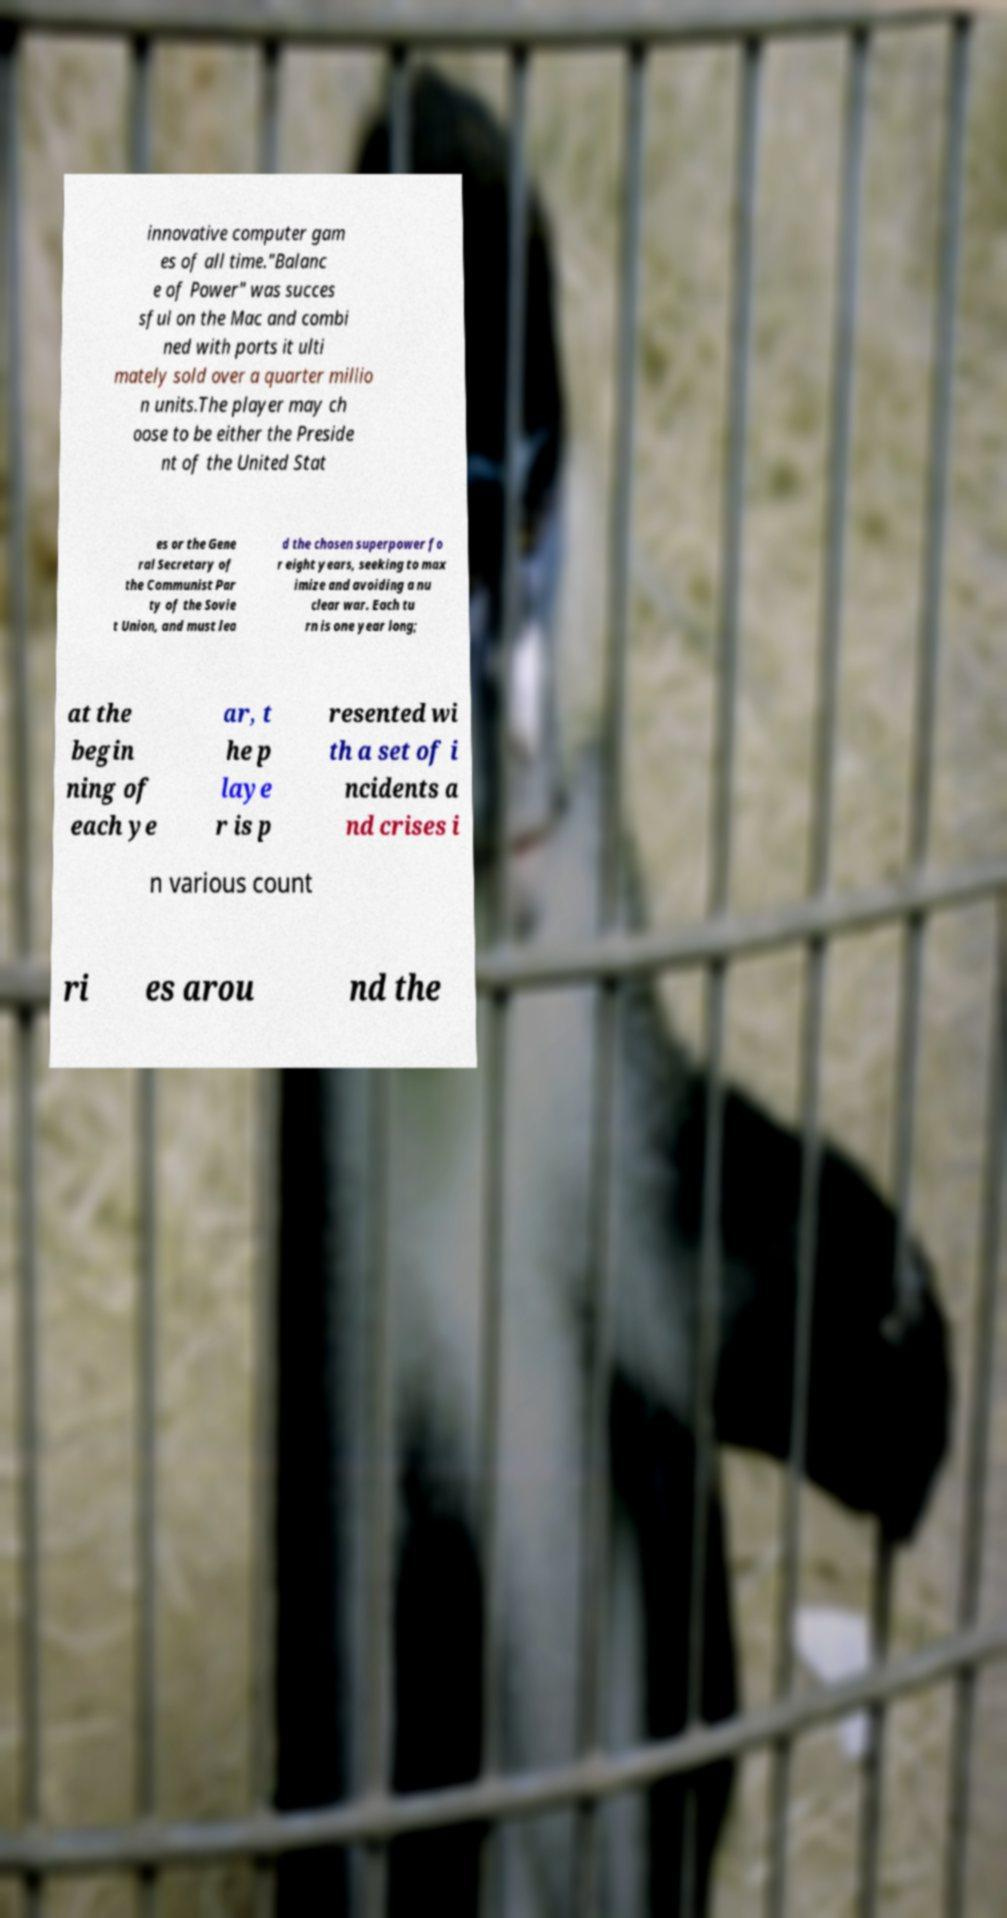What messages or text are displayed in this image? I need them in a readable, typed format. innovative computer gam es of all time."Balanc e of Power" was succes sful on the Mac and combi ned with ports it ulti mately sold over a quarter millio n units.The player may ch oose to be either the Preside nt of the United Stat es or the Gene ral Secretary of the Communist Par ty of the Sovie t Union, and must lea d the chosen superpower fo r eight years, seeking to max imize and avoiding a nu clear war. Each tu rn is one year long; at the begin ning of each ye ar, t he p laye r is p resented wi th a set of i ncidents a nd crises i n various count ri es arou nd the 